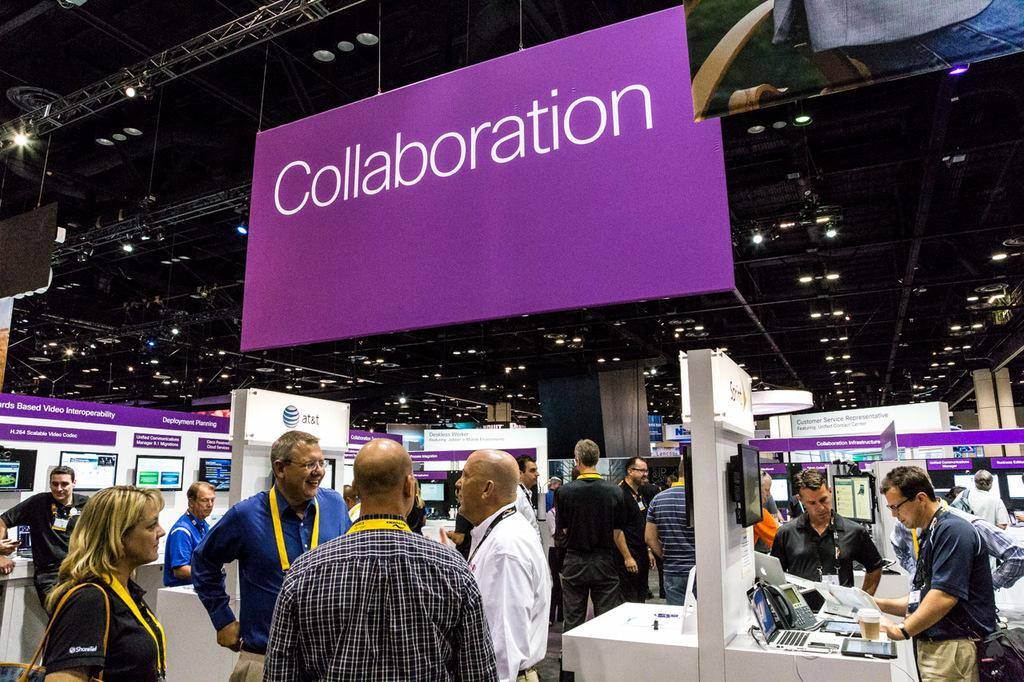How many people can be seen in the image? There are many people present in the image. What objects are visible in the image besides the people? There are telephones and other objects in the image. What is hanging on the wall or ceiling in the image? There is a board hanging in the image. What type of lighting is present in the image? There are lights on the top of the image. What shape is the truck in the image? There is no truck present in the image. What type of bag is being used by the people in the image? There is no bag visible in the image. 